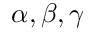<formula> <loc_0><loc_0><loc_500><loc_500>\alpha , \beta , \gamma</formula> 